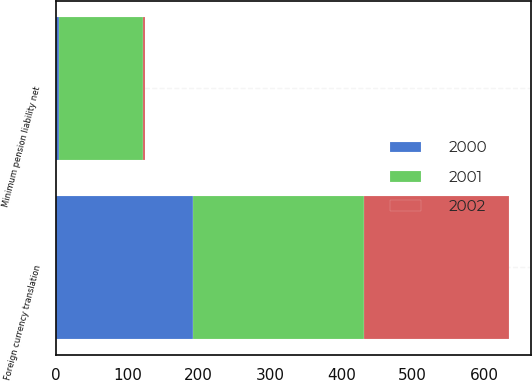Convert chart. <chart><loc_0><loc_0><loc_500><loc_500><stacked_bar_chart><ecel><fcel>Foreign currency translation<fcel>Minimum pension liability net<nl><fcel>2001<fcel>239.6<fcel>117<nl><fcel>2000<fcel>191.8<fcel>4.6<nl><fcel>2002<fcel>202.8<fcel>3.3<nl></chart> 